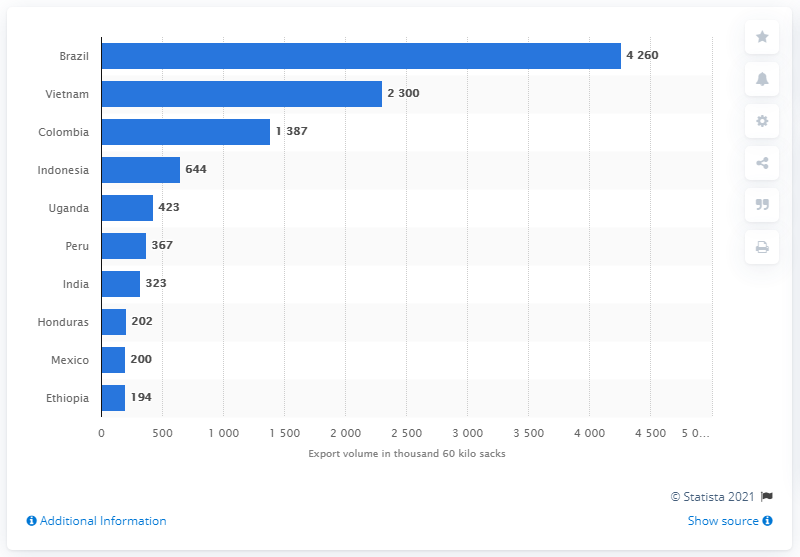Draw attention to some important aspects in this diagram. In 2020, Brazil exported the highest volume of coffee, making it the leading exporter of coffee globally. 